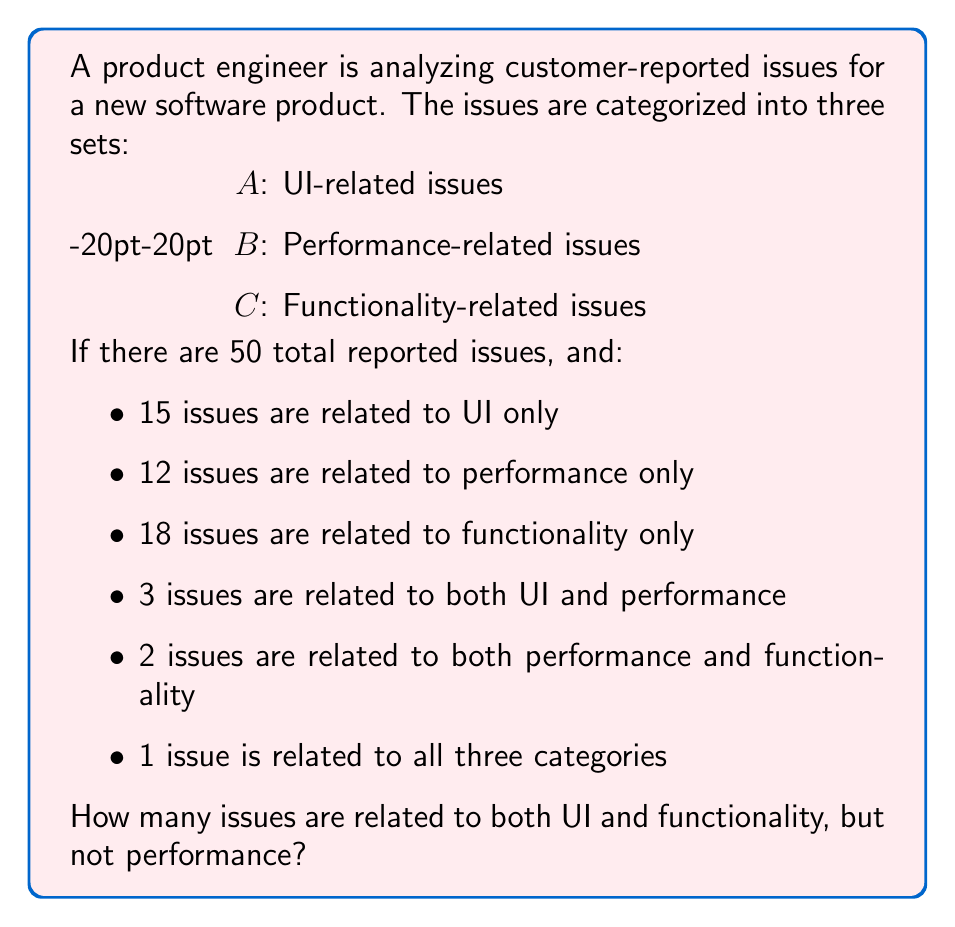Help me with this question. Let's approach this step-by-step using set theory:

1) First, let's define our universal set U as all reported issues:
   $|U| = 50$

2) We can represent the given information using set notation:
   $|A| = $ UI-related issues
   $|B| = $ Performance-related issues
   $|C| = $ Functionality-related issues
   $|A \cap B| = 3$
   $|B \cap C| = 2$
   $|A \cap B \cap C| = 1$

3) We're also given the number of issues that belong to each set exclusively:
   $|A - (B \cup C)| = 15$
   $|B - (A \cup C)| = 12$
   $|C - (A \cup B)| = 18$

4) We need to find $|A \cap C| - |A \cap B \cap C|$, which represents issues related to both UI and functionality, but not performance.

5) To solve this, let's use the inclusion-exclusion principle:
   $|A \cup B \cup C| = |A| + |B| + |C| - |A \cap B| - |A \cap C| - |B \cap C| + |A \cap B \cap C|$

6) We know the left side of the equation is 50 (total issues). Let's substitute the known values:
   $50 = |A| + |B| + |C| - 3 - |A \cap C| - 2 + 1$

7) Now, we can calculate $|A|$, $|B|$, and $|C|$ using the exclusive counts:
   $|A| = 15 + 3 + |A \cap C| + 1 = 19 + |A \cap C|$
   $|B| = 12 + 3 + 2 + 1 = 18$
   $|C| = 18 + 2 + |A \cap C| + 1 = 21 + |A \cap C|$

8) Substituting these into our equation:
   $50 = (19 + |A \cap C|) + 18 + (21 + |A \cap C|) - 3 - |A \cap C| - 2 + 1$

9) Simplifying:
   $50 = 54 + |A \cap C|$
   $|A \cap C| = 50 - 54 = -4$

10) Therefore, $|A \cap C| = 4$

11) The question asks for $|A \cap C| - |A \cap B \cap C| = 4 - 1 = 3$
Answer: 3 issues 